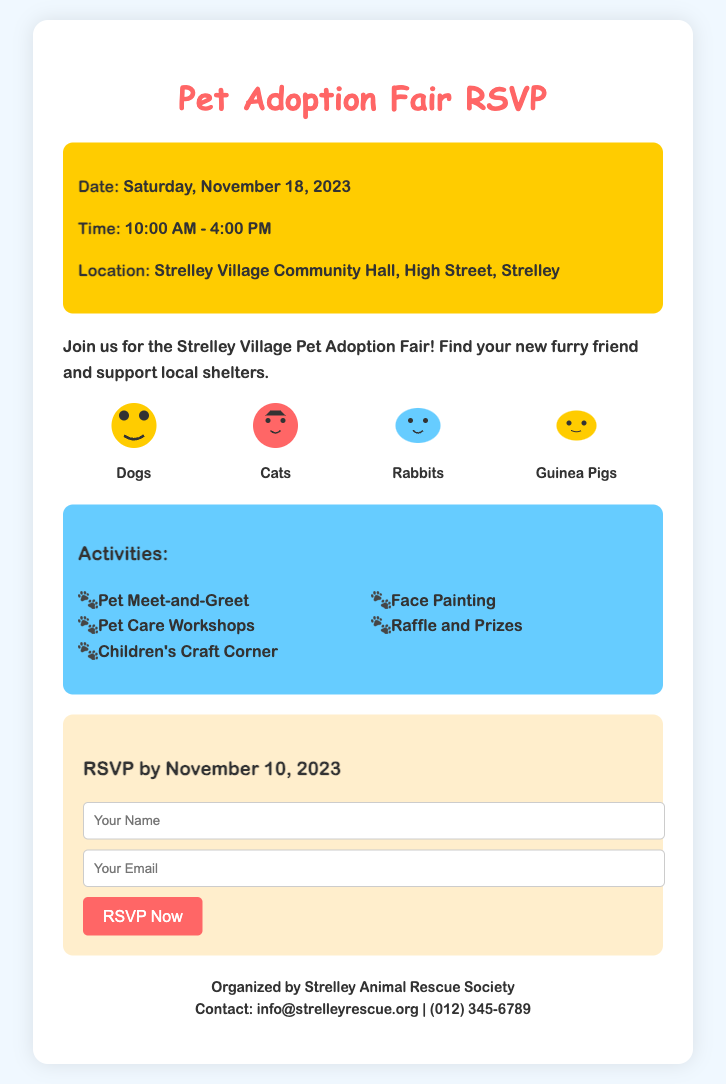What is the date of the Pet Adoption Fair? The date is specified in the document as Saturday, November 18, 2023.
Answer: Saturday, November 18, 2023 What are the operating hours for the event? The time is provided in the document as 10:00 AM - 4:00 PM.
Answer: 10:00 AM - 4:00 PM Where is the location of the adoption fair? The location is mentioned in the document as Strelley Village Community Hall, High Street, Strelley.
Answer: Strelley Village Community Hall, High Street, Strelley Which types of animals are available for adoption? The document lists different types including Dogs, Cats, Rabbits, and Guinea Pigs.
Answer: Dogs, Cats, Rabbits, Guinea Pigs What activities will be available at the fair? The activities section lists various events including Pet Meet-and-Greet and Face Painting.
Answer: Pet Meet-and-Greet, Pet Care Workshops, Children's Craft Corner, Face Painting, Raffle and Prizes When is the RSVP deadline? The RSVP by date is stated in the document as November 10, 2023.
Answer: November 10, 2023 What is the contact email for the organizing society? The contact information lists an email address for inquiries, which is info@strelleyrescue.org.
Answer: info@strelleyrescue.org How can I RSVP for the event? The RSVP method is provided as filling out a form with name and email, and submitting it online.
Answer: Filling out a form online What is the color theme of the RSVP card? The document describes a vibrant color scheme including yellow, blue, and pink backgrounds.
Answer: Vibrant colors including yellow, blue, and pink 